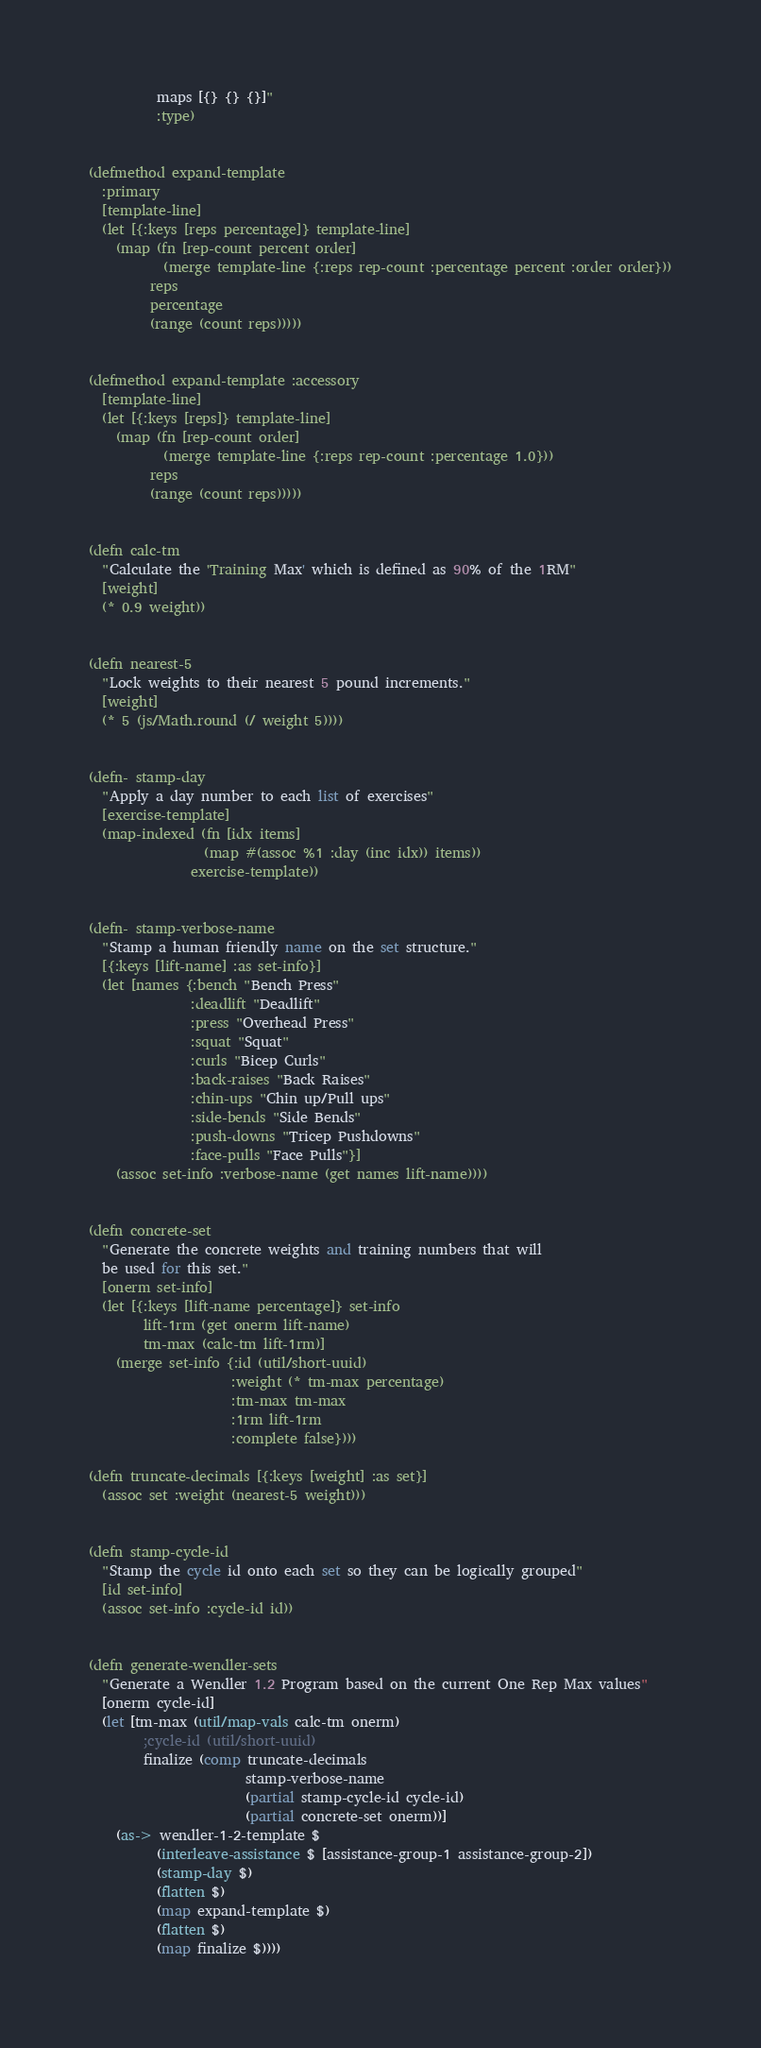<code> <loc_0><loc_0><loc_500><loc_500><_Clojure_>          maps [{} {} {}]"
          :type)


(defmethod expand-template
  :primary
  [template-line]
  (let [{:keys [reps percentage]} template-line]
    (map (fn [rep-count percent order]
           (merge template-line {:reps rep-count :percentage percent :order order}))
         reps
         percentage
         (range (count reps)))))


(defmethod expand-template :accessory
  [template-line]
  (let [{:keys [reps]} template-line]
    (map (fn [rep-count order]
           (merge template-line {:reps rep-count :percentage 1.0}))
         reps
         (range (count reps)))))


(defn calc-tm
  "Calculate the 'Training Max' which is defined as 90% of the 1RM"
  [weight]
  (* 0.9 weight))


(defn nearest-5
  "Lock weights to their nearest 5 pound increments."
  [weight]
  (* 5 (js/Math.round (/ weight 5))))


(defn- stamp-day
  "Apply a day number to each list of exercises"
  [exercise-template]
  (map-indexed (fn [idx items]
                 (map #(assoc %1 :day (inc idx)) items))
               exercise-template))


(defn- stamp-verbose-name
  "Stamp a human friendly name on the set structure."
  [{:keys [lift-name] :as set-info}]
  (let [names {:bench "Bench Press"
               :deadlift "Deadlift"
               :press "Overhead Press"
               :squat "Squat"
               :curls "Bicep Curls"
               :back-raises "Back Raises"
               :chin-ups "Chin up/Pull ups"
               :side-bends "Side Bends"
               :push-downs "Tricep Pushdowns"
               :face-pulls "Face Pulls"}]
    (assoc set-info :verbose-name (get names lift-name))))


(defn concrete-set
  "Generate the concrete weights and training numbers that will
  be used for this set."
  [onerm set-info]
  (let [{:keys [lift-name percentage]} set-info
        lift-1rm (get onerm lift-name)
        tm-max (calc-tm lift-1rm)]
    (merge set-info {:id (util/short-uuid)
                     :weight (* tm-max percentage)
                     :tm-max tm-max
                     :1rm lift-1rm
                     :complete false})))

(defn truncate-decimals [{:keys [weight] :as set}]
  (assoc set :weight (nearest-5 weight)))


(defn stamp-cycle-id
  "Stamp the cycle id onto each set so they can be logically grouped"
  [id set-info]
  (assoc set-info :cycle-id id))


(defn generate-wendler-sets
  "Generate a Wendler 1.2 Program based on the current One Rep Max values"
  [onerm cycle-id]
  (let [tm-max (util/map-vals calc-tm onerm)
        ;cycle-id (util/short-uuid)
        finalize (comp truncate-decimals
                       stamp-verbose-name
                       (partial stamp-cycle-id cycle-id)
                       (partial concrete-set onerm))]
    (as-> wendler-1-2-template $
          (interleave-assistance $ [assistance-group-1 assistance-group-2])
          (stamp-day $)
          (flatten $)
          (map expand-template $)
          (flatten $)
          (map finalize $))))

</code> 